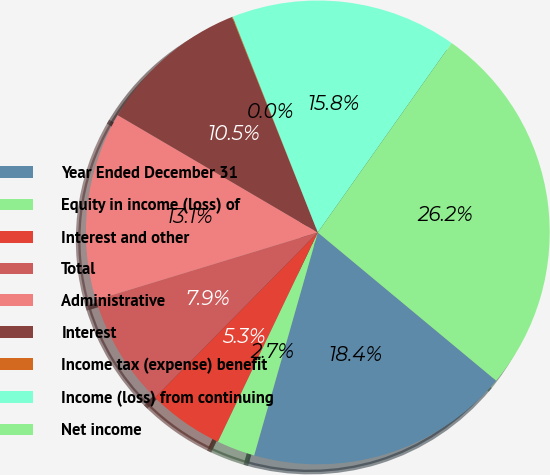Convert chart to OTSL. <chart><loc_0><loc_0><loc_500><loc_500><pie_chart><fcel>Year Ended December 31<fcel>Equity in income (loss) of<fcel>Interest and other<fcel>Total<fcel>Administrative<fcel>Interest<fcel>Income tax (expense) benefit<fcel>Income (loss) from continuing<fcel>Net income<nl><fcel>18.39%<fcel>2.67%<fcel>5.29%<fcel>7.91%<fcel>13.15%<fcel>10.53%<fcel>0.05%<fcel>15.77%<fcel>26.25%<nl></chart> 